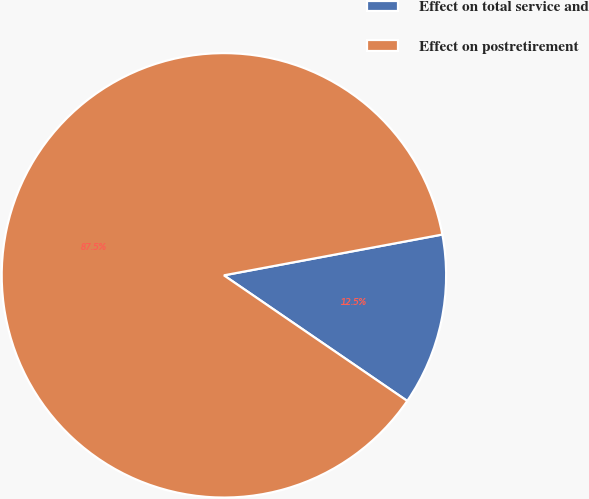Convert chart. <chart><loc_0><loc_0><loc_500><loc_500><pie_chart><fcel>Effect on total service and<fcel>Effect on postretirement<nl><fcel>12.5%<fcel>87.5%<nl></chart> 